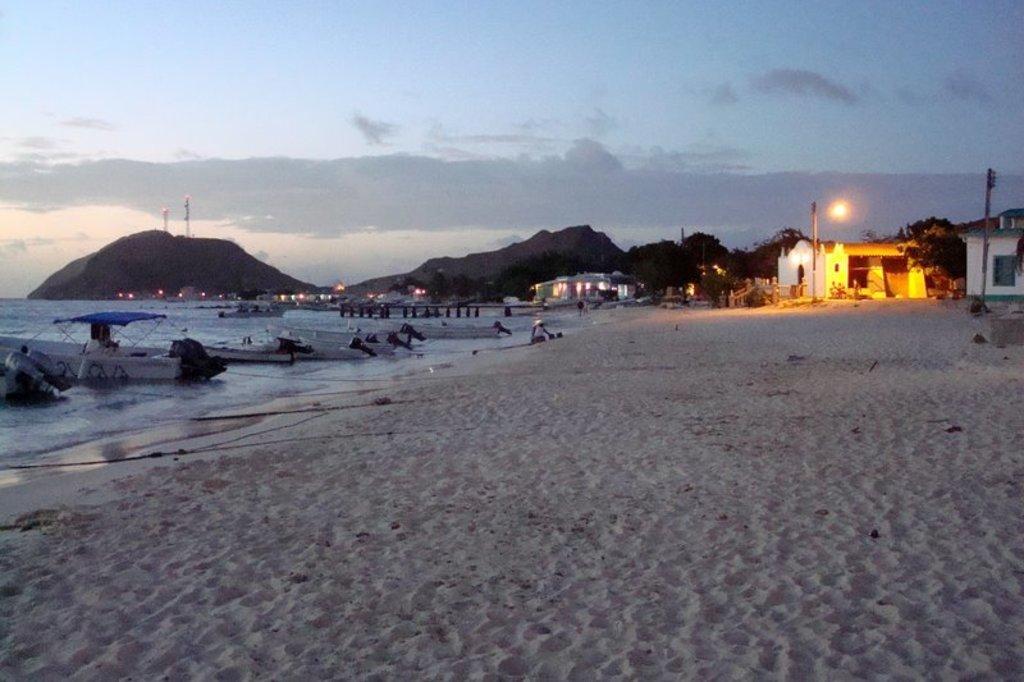In one or two sentences, can you explain what this image depicts? In this image we can see water, boats, sand, houses, lights, hills, sky and clouds. 